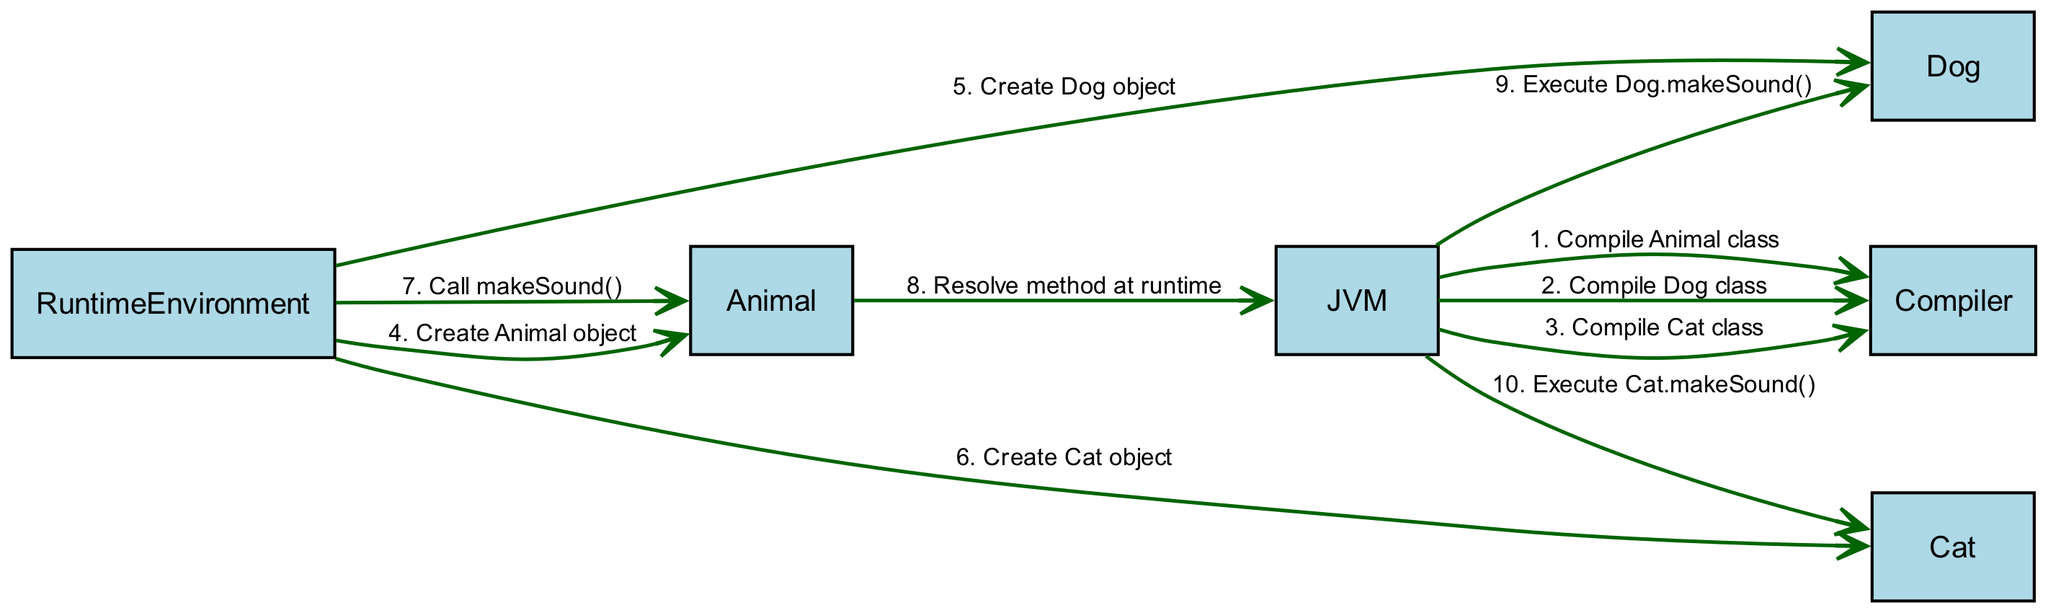What are the actors in the diagram? The actors listed in the diagram are JVM, Compiler, and RuntimeEnvironment. These entities perform specific roles in the dynamic method dispatch process.
Answer: JVM, Compiler, RuntimeEnvironment How many objects are represented in the diagram? The diagram includes three objects: Animal, Dog, and Cat, which are part of the polymorphic inheritance hierarchy.
Answer: 3 What message comes after "Compile Dog class"? The next message after "Compile Dog class" is "Compile Cat class", as you can see from the sequence of messages listed in the diagram.
Answer: Compile Cat class Which object is created first? The first object created is the Animal object, as indicated by the first message directed to it from the RuntimeEnvironment.
Answer: Animal object What action does the RuntimeEnvironment perform last? The last action performed by the RuntimeEnvironment is "Call makeSound()", which initiates the dynamic method dispatch process.
Answer: Call makeSound() Who resolves the method at runtime? The method is resolved at runtime by the JVM, as shown in the message flow where Animal sends a request back to the JVM to resolve the method.
Answer: JVM How many times does the JVM execute a method after resolution? The JVM executes methods two times after resolution: once for Dog.makeSound() and once for Cat.makeSound().
Answer: 2 Which object does the JVM execute after resolving "makeSound()" for Animal? After resolving "makeSound()", the JVM executes Dog.makeSound() first, as indicated in the message sequence.
Answer: Dog.makeSound() What is the last object that the JVM interacts with in the diagram? The last object that the JVM interacts with is Cat since its makeSound() method is executed last in the sequence.
Answer: Cat 